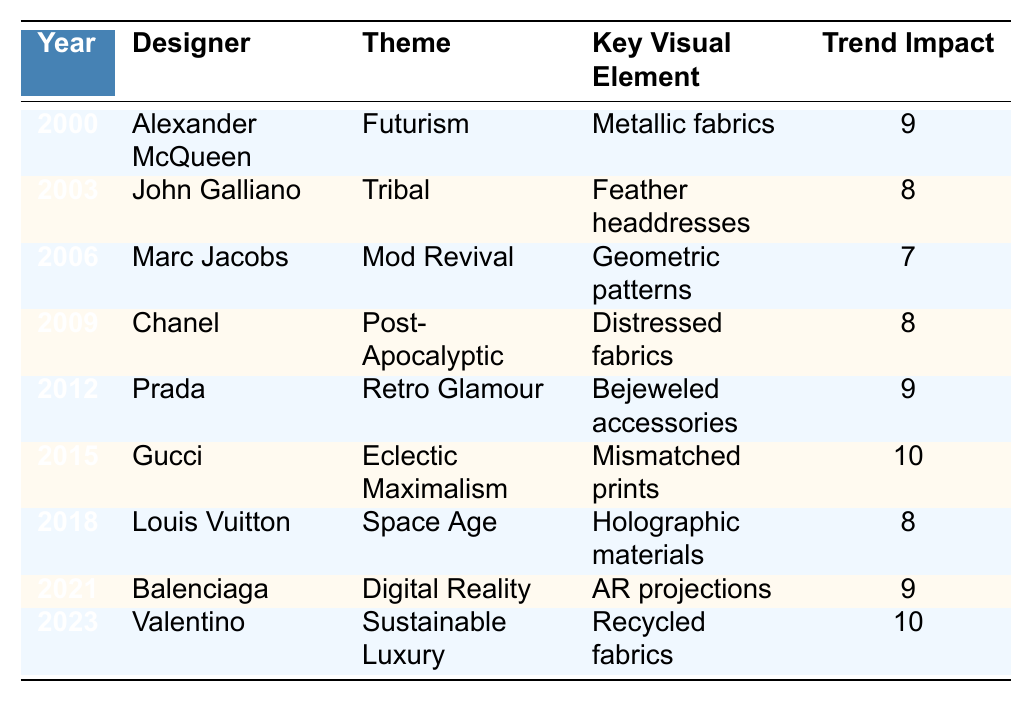What was the theme of the 2015 runway show? In the year 2015, the designer Gucci presented the theme "Eclectic Maximalism" as per the data in the table.
Answer: Eclectic Maximalism Which designer featured a theme related to sustainability in 2023? The designer Valentino was associated with the theme "Sustainable Luxury" in 2023, as indicated in the table.
Answer: Valentino How many runway shows had a trend impact rating of 10? From the table, two shows had a trend impact rating of 10: Gucci in 2015 and Valentino in 2023.
Answer: 2 What was the key visual element of the 2006 runway show? The key visual element for the 2006 show by Marc Jacobs was "Geometric patterns", as noted in the table.
Answer: Geometric patterns Is the statement "Chanel's 2009 theme was Retro Glamour" true or false? According to the table, Chanel's theme in 2009 was "Post-Apocalyptic," so the statement is false.
Answer: False Which theme had the highest trend impact rating in the data? The themes “Eclectic Maximalism” by Gucci (2015) and “Sustainable Luxury” by Valentino (2023) both had the highest trend impact rating of 10.
Answer: Eclectic Maximalism and Sustainable Luxury What is the difference in trend impact scores between the theme of 2000 and the theme of 2021? The trend impact score for the theme in the year 2000 (Futurism) is 9 and for 2021 (Digital Reality) is also 9. Therefore, the difference is 9 - 9 = 0.
Answer: 0 List the years when the theme had a trend impact of at least 8. The years with a trend impact of at least 8 are: 2000, 2003, 2009, 2012, 2015, 2018, 2021, and 2023, making it a total of 8 years.
Answer: 8 years What was the visual element associated with the "Space Age" theme? The visual element associated with the "Space Age" theme (shown by Louis Vuitton in 2018) was "Holographic materials," as mentioned in the table.
Answer: Holographic materials Which designer had the second-highest trend impact and what was the year? The designer Prada had a trend impact of 9 in 2012, which is the second-highest after Gucci and Valentino’s 10.
Answer: Prada, 2012 